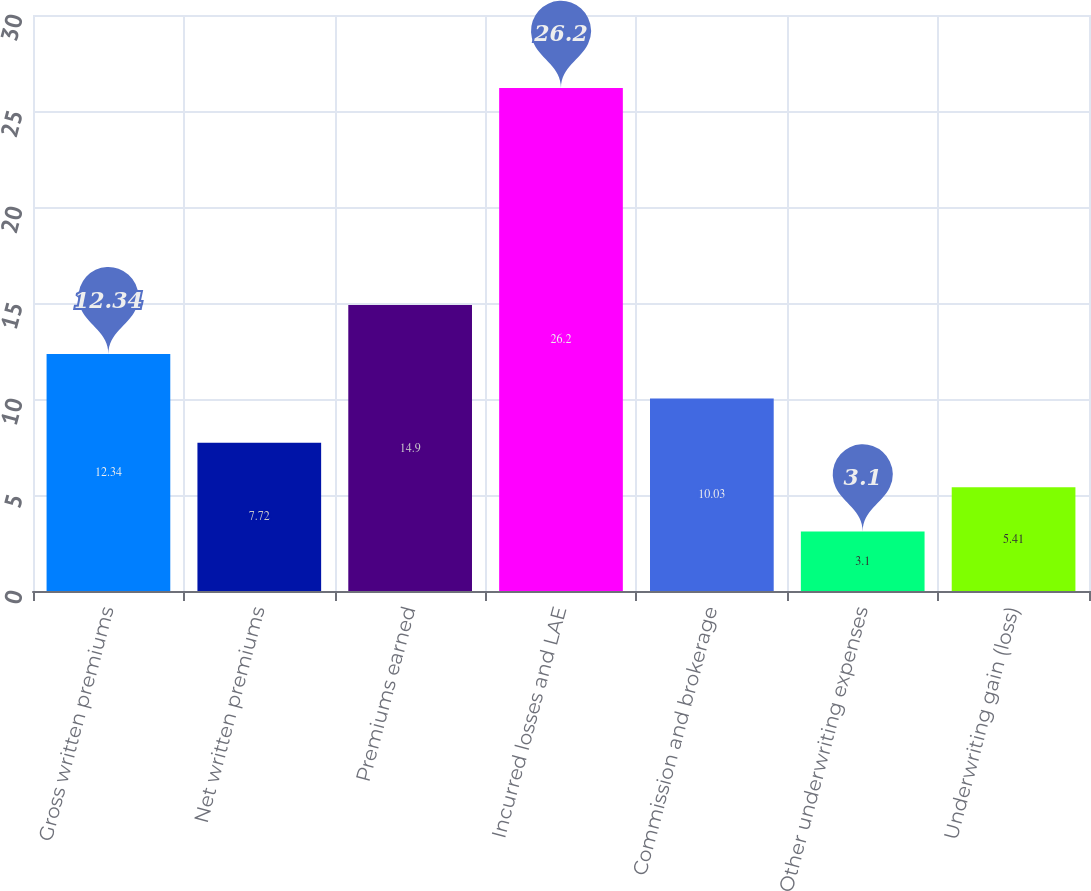<chart> <loc_0><loc_0><loc_500><loc_500><bar_chart><fcel>Gross written premiums<fcel>Net written premiums<fcel>Premiums earned<fcel>Incurred losses and LAE<fcel>Commission and brokerage<fcel>Other underwriting expenses<fcel>Underwriting gain (loss)<nl><fcel>12.34<fcel>7.72<fcel>14.9<fcel>26.2<fcel>10.03<fcel>3.1<fcel>5.41<nl></chart> 